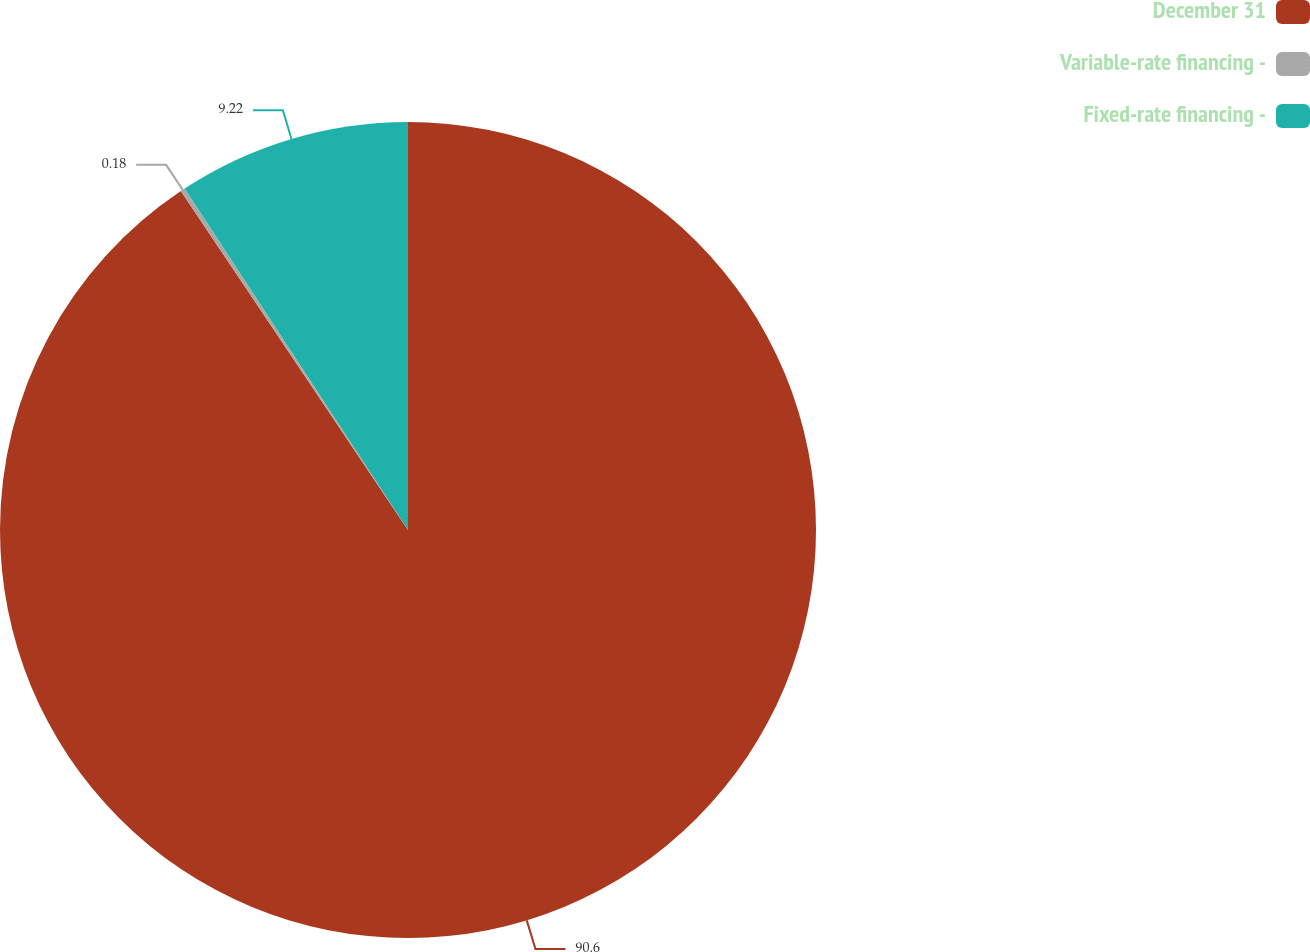Convert chart. <chart><loc_0><loc_0><loc_500><loc_500><pie_chart><fcel>December 31<fcel>Variable-rate financing -<fcel>Fixed-rate financing -<nl><fcel>90.6%<fcel>0.18%<fcel>9.22%<nl></chart> 